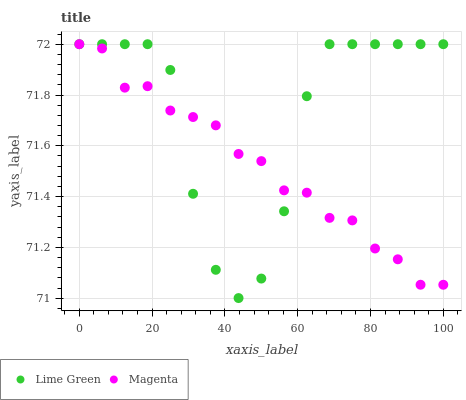Does Magenta have the minimum area under the curve?
Answer yes or no. Yes. Does Lime Green have the maximum area under the curve?
Answer yes or no. Yes. Does Lime Green have the minimum area under the curve?
Answer yes or no. No. Is Magenta the smoothest?
Answer yes or no. Yes. Is Lime Green the roughest?
Answer yes or no. Yes. Is Lime Green the smoothest?
Answer yes or no. No. Does Lime Green have the lowest value?
Answer yes or no. Yes. Does Lime Green have the highest value?
Answer yes or no. Yes. Does Lime Green intersect Magenta?
Answer yes or no. Yes. Is Lime Green less than Magenta?
Answer yes or no. No. Is Lime Green greater than Magenta?
Answer yes or no. No. 